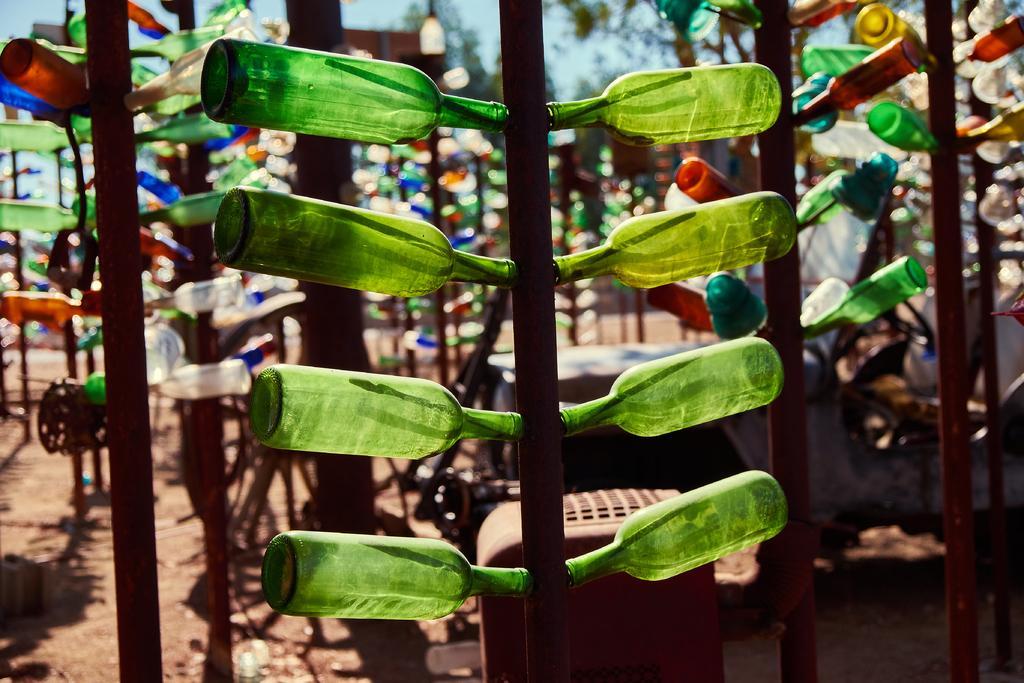Describe this image in one or two sentences. There is a brown color pole and to the either side of the pole there are lot of bottles attached to the pole. In the background there is a sky,lights and trees. 